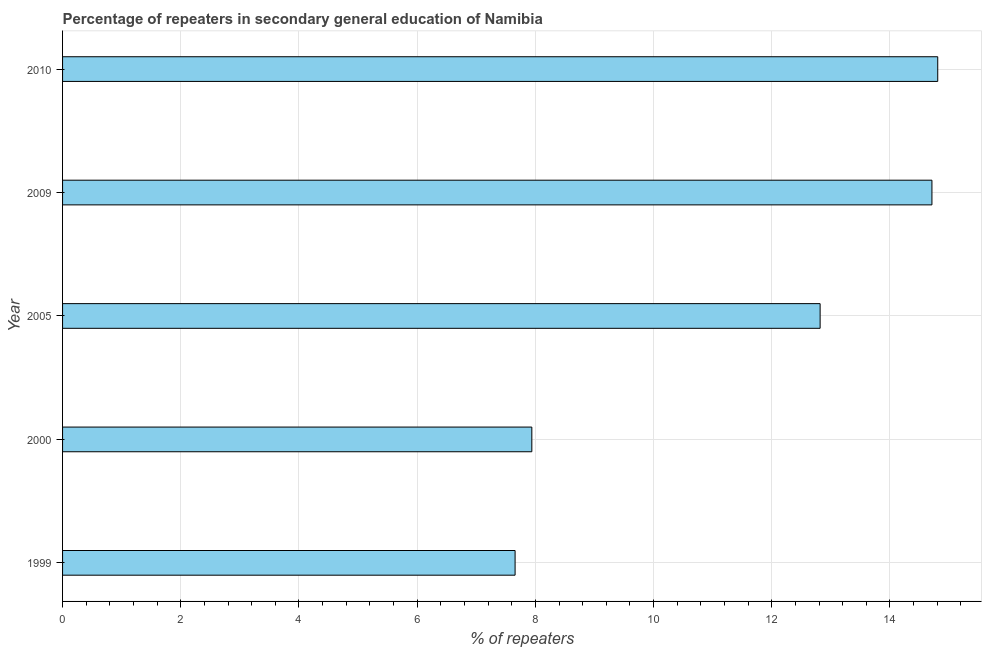Does the graph contain grids?
Your answer should be compact. Yes. What is the title of the graph?
Offer a terse response. Percentage of repeaters in secondary general education of Namibia. What is the label or title of the X-axis?
Keep it short and to the point. % of repeaters. What is the percentage of repeaters in 2005?
Your answer should be compact. 12.82. Across all years, what is the maximum percentage of repeaters?
Offer a terse response. 14.81. Across all years, what is the minimum percentage of repeaters?
Your answer should be very brief. 7.66. In which year was the percentage of repeaters maximum?
Offer a terse response. 2010. What is the sum of the percentage of repeaters?
Your answer should be compact. 57.93. What is the difference between the percentage of repeaters in 1999 and 2009?
Ensure brevity in your answer.  -7.05. What is the average percentage of repeaters per year?
Offer a terse response. 11.59. What is the median percentage of repeaters?
Offer a terse response. 12.82. What is the ratio of the percentage of repeaters in 2005 to that in 2010?
Your response must be concise. 0.87. What is the difference between the highest and the second highest percentage of repeaters?
Keep it short and to the point. 0.1. Is the sum of the percentage of repeaters in 1999 and 2005 greater than the maximum percentage of repeaters across all years?
Your answer should be compact. Yes. What is the difference between the highest and the lowest percentage of repeaters?
Your response must be concise. 7.15. In how many years, is the percentage of repeaters greater than the average percentage of repeaters taken over all years?
Your answer should be very brief. 3. How many bars are there?
Provide a succinct answer. 5. Are all the bars in the graph horizontal?
Provide a succinct answer. Yes. Are the values on the major ticks of X-axis written in scientific E-notation?
Give a very brief answer. No. What is the % of repeaters of 1999?
Offer a very short reply. 7.66. What is the % of repeaters of 2000?
Offer a terse response. 7.94. What is the % of repeaters of 2005?
Your answer should be compact. 12.82. What is the % of repeaters of 2009?
Ensure brevity in your answer.  14.71. What is the % of repeaters of 2010?
Your answer should be compact. 14.81. What is the difference between the % of repeaters in 1999 and 2000?
Offer a terse response. -0.28. What is the difference between the % of repeaters in 1999 and 2005?
Your answer should be compact. -5.16. What is the difference between the % of repeaters in 1999 and 2009?
Provide a short and direct response. -7.05. What is the difference between the % of repeaters in 1999 and 2010?
Make the answer very short. -7.15. What is the difference between the % of repeaters in 2000 and 2005?
Your response must be concise. -4.88. What is the difference between the % of repeaters in 2000 and 2009?
Ensure brevity in your answer.  -6.77. What is the difference between the % of repeaters in 2000 and 2010?
Provide a succinct answer. -6.87. What is the difference between the % of repeaters in 2005 and 2009?
Your answer should be compact. -1.89. What is the difference between the % of repeaters in 2005 and 2010?
Provide a succinct answer. -1.99. What is the difference between the % of repeaters in 2009 and 2010?
Your response must be concise. -0.1. What is the ratio of the % of repeaters in 1999 to that in 2005?
Your response must be concise. 0.6. What is the ratio of the % of repeaters in 1999 to that in 2009?
Provide a short and direct response. 0.52. What is the ratio of the % of repeaters in 1999 to that in 2010?
Your response must be concise. 0.52. What is the ratio of the % of repeaters in 2000 to that in 2005?
Provide a short and direct response. 0.62. What is the ratio of the % of repeaters in 2000 to that in 2009?
Offer a very short reply. 0.54. What is the ratio of the % of repeaters in 2000 to that in 2010?
Your response must be concise. 0.54. What is the ratio of the % of repeaters in 2005 to that in 2009?
Your response must be concise. 0.87. What is the ratio of the % of repeaters in 2005 to that in 2010?
Make the answer very short. 0.87. 